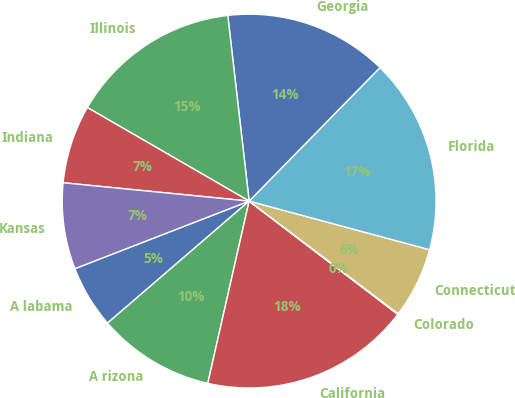Convert chart. <chart><loc_0><loc_0><loc_500><loc_500><pie_chart><fcel>A labama<fcel>A rizona<fcel>California<fcel>Colorado<fcel>Connecticut<fcel>Florida<fcel>Georgia<fcel>Illinois<fcel>Indiana<fcel>Kansas<nl><fcel>5.43%<fcel>10.13%<fcel>18.19%<fcel>0.06%<fcel>6.11%<fcel>16.85%<fcel>14.16%<fcel>14.83%<fcel>6.78%<fcel>7.45%<nl></chart> 